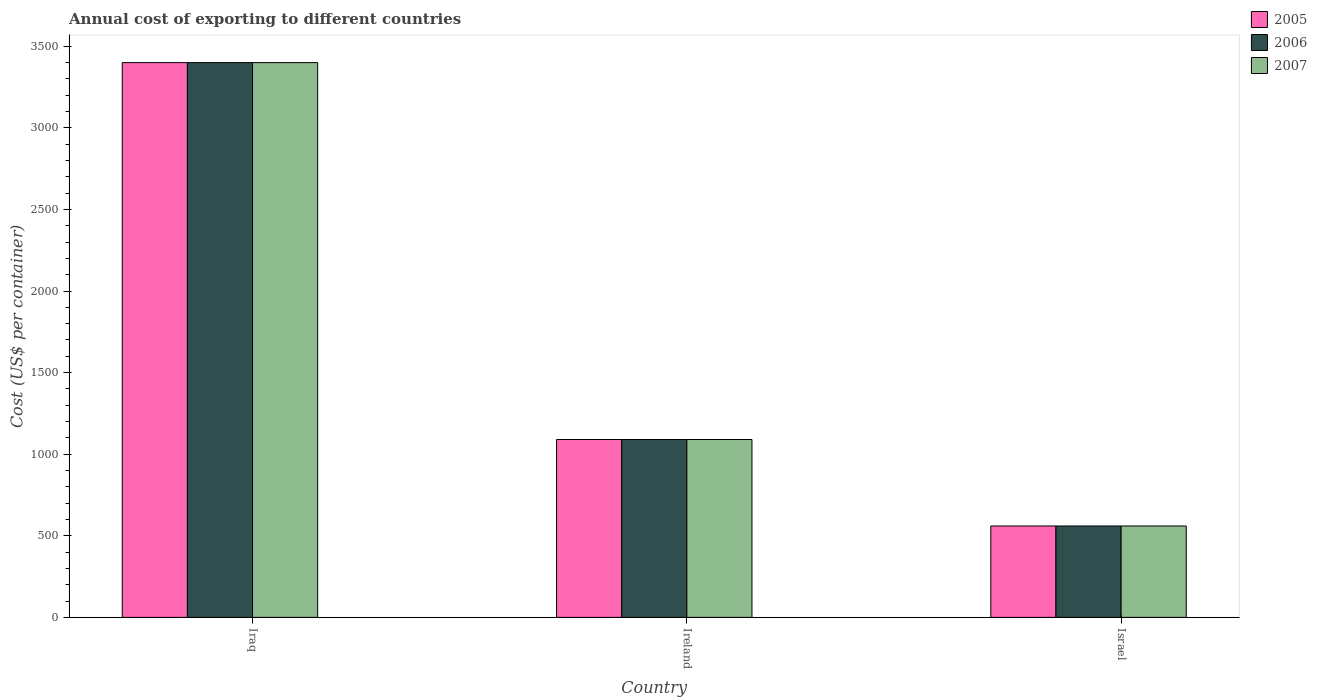How many groups of bars are there?
Give a very brief answer. 3. Are the number of bars per tick equal to the number of legend labels?
Keep it short and to the point. Yes. Are the number of bars on each tick of the X-axis equal?
Your response must be concise. Yes. How many bars are there on the 3rd tick from the left?
Keep it short and to the point. 3. How many bars are there on the 2nd tick from the right?
Ensure brevity in your answer.  3. What is the label of the 1st group of bars from the left?
Your response must be concise. Iraq. In how many cases, is the number of bars for a given country not equal to the number of legend labels?
Provide a short and direct response. 0. What is the total annual cost of exporting in 2005 in Israel?
Give a very brief answer. 560. Across all countries, what is the maximum total annual cost of exporting in 2007?
Your answer should be compact. 3400. Across all countries, what is the minimum total annual cost of exporting in 2006?
Offer a terse response. 560. In which country was the total annual cost of exporting in 2005 maximum?
Your answer should be very brief. Iraq. What is the total total annual cost of exporting in 2005 in the graph?
Offer a very short reply. 5050. What is the difference between the total annual cost of exporting in 2005 in Ireland and that in Israel?
Offer a very short reply. 530. What is the difference between the total annual cost of exporting in 2007 in Israel and the total annual cost of exporting in 2005 in Iraq?
Offer a very short reply. -2840. What is the average total annual cost of exporting in 2006 per country?
Provide a succinct answer. 1683.33. What is the difference between the total annual cost of exporting of/in 2006 and total annual cost of exporting of/in 2007 in Israel?
Your answer should be compact. 0. What is the ratio of the total annual cost of exporting in 2007 in Ireland to that in Israel?
Make the answer very short. 1.95. Is the difference between the total annual cost of exporting in 2006 in Ireland and Israel greater than the difference between the total annual cost of exporting in 2007 in Ireland and Israel?
Offer a very short reply. No. What is the difference between the highest and the second highest total annual cost of exporting in 2006?
Your answer should be compact. 2310. What is the difference between the highest and the lowest total annual cost of exporting in 2006?
Keep it short and to the point. 2840. In how many countries, is the total annual cost of exporting in 2006 greater than the average total annual cost of exporting in 2006 taken over all countries?
Provide a succinct answer. 1. What does the 3rd bar from the left in Ireland represents?
Your response must be concise. 2007. What does the 3rd bar from the right in Israel represents?
Your response must be concise. 2005. Is it the case that in every country, the sum of the total annual cost of exporting in 2005 and total annual cost of exporting in 2006 is greater than the total annual cost of exporting in 2007?
Your response must be concise. Yes. How many countries are there in the graph?
Offer a terse response. 3. Are the values on the major ticks of Y-axis written in scientific E-notation?
Your answer should be very brief. No. Does the graph contain grids?
Ensure brevity in your answer.  No. Where does the legend appear in the graph?
Your response must be concise. Top right. How many legend labels are there?
Provide a short and direct response. 3. What is the title of the graph?
Ensure brevity in your answer.  Annual cost of exporting to different countries. Does "2011" appear as one of the legend labels in the graph?
Offer a very short reply. No. What is the label or title of the X-axis?
Offer a very short reply. Country. What is the label or title of the Y-axis?
Give a very brief answer. Cost (US$ per container). What is the Cost (US$ per container) in 2005 in Iraq?
Your answer should be very brief. 3400. What is the Cost (US$ per container) in 2006 in Iraq?
Ensure brevity in your answer.  3400. What is the Cost (US$ per container) in 2007 in Iraq?
Provide a short and direct response. 3400. What is the Cost (US$ per container) in 2005 in Ireland?
Make the answer very short. 1090. What is the Cost (US$ per container) of 2006 in Ireland?
Offer a very short reply. 1090. What is the Cost (US$ per container) in 2007 in Ireland?
Offer a very short reply. 1090. What is the Cost (US$ per container) in 2005 in Israel?
Offer a very short reply. 560. What is the Cost (US$ per container) in 2006 in Israel?
Your response must be concise. 560. What is the Cost (US$ per container) in 2007 in Israel?
Make the answer very short. 560. Across all countries, what is the maximum Cost (US$ per container) of 2005?
Your answer should be compact. 3400. Across all countries, what is the maximum Cost (US$ per container) of 2006?
Your answer should be compact. 3400. Across all countries, what is the maximum Cost (US$ per container) of 2007?
Keep it short and to the point. 3400. Across all countries, what is the minimum Cost (US$ per container) of 2005?
Keep it short and to the point. 560. Across all countries, what is the minimum Cost (US$ per container) in 2006?
Offer a terse response. 560. Across all countries, what is the minimum Cost (US$ per container) in 2007?
Offer a very short reply. 560. What is the total Cost (US$ per container) of 2005 in the graph?
Keep it short and to the point. 5050. What is the total Cost (US$ per container) of 2006 in the graph?
Ensure brevity in your answer.  5050. What is the total Cost (US$ per container) in 2007 in the graph?
Your answer should be compact. 5050. What is the difference between the Cost (US$ per container) in 2005 in Iraq and that in Ireland?
Provide a short and direct response. 2310. What is the difference between the Cost (US$ per container) of 2006 in Iraq and that in Ireland?
Keep it short and to the point. 2310. What is the difference between the Cost (US$ per container) in 2007 in Iraq and that in Ireland?
Your answer should be very brief. 2310. What is the difference between the Cost (US$ per container) in 2005 in Iraq and that in Israel?
Ensure brevity in your answer.  2840. What is the difference between the Cost (US$ per container) in 2006 in Iraq and that in Israel?
Offer a very short reply. 2840. What is the difference between the Cost (US$ per container) of 2007 in Iraq and that in Israel?
Provide a succinct answer. 2840. What is the difference between the Cost (US$ per container) in 2005 in Ireland and that in Israel?
Offer a very short reply. 530. What is the difference between the Cost (US$ per container) of 2006 in Ireland and that in Israel?
Ensure brevity in your answer.  530. What is the difference between the Cost (US$ per container) of 2007 in Ireland and that in Israel?
Make the answer very short. 530. What is the difference between the Cost (US$ per container) in 2005 in Iraq and the Cost (US$ per container) in 2006 in Ireland?
Your response must be concise. 2310. What is the difference between the Cost (US$ per container) of 2005 in Iraq and the Cost (US$ per container) of 2007 in Ireland?
Make the answer very short. 2310. What is the difference between the Cost (US$ per container) in 2006 in Iraq and the Cost (US$ per container) in 2007 in Ireland?
Provide a short and direct response. 2310. What is the difference between the Cost (US$ per container) of 2005 in Iraq and the Cost (US$ per container) of 2006 in Israel?
Provide a succinct answer. 2840. What is the difference between the Cost (US$ per container) of 2005 in Iraq and the Cost (US$ per container) of 2007 in Israel?
Ensure brevity in your answer.  2840. What is the difference between the Cost (US$ per container) of 2006 in Iraq and the Cost (US$ per container) of 2007 in Israel?
Make the answer very short. 2840. What is the difference between the Cost (US$ per container) in 2005 in Ireland and the Cost (US$ per container) in 2006 in Israel?
Make the answer very short. 530. What is the difference between the Cost (US$ per container) of 2005 in Ireland and the Cost (US$ per container) of 2007 in Israel?
Make the answer very short. 530. What is the difference between the Cost (US$ per container) of 2006 in Ireland and the Cost (US$ per container) of 2007 in Israel?
Offer a terse response. 530. What is the average Cost (US$ per container) in 2005 per country?
Give a very brief answer. 1683.33. What is the average Cost (US$ per container) in 2006 per country?
Offer a very short reply. 1683.33. What is the average Cost (US$ per container) of 2007 per country?
Give a very brief answer. 1683.33. What is the difference between the Cost (US$ per container) of 2005 and Cost (US$ per container) of 2006 in Ireland?
Offer a terse response. 0. What is the difference between the Cost (US$ per container) of 2005 and Cost (US$ per container) of 2007 in Israel?
Your response must be concise. 0. What is the difference between the Cost (US$ per container) of 2006 and Cost (US$ per container) of 2007 in Israel?
Keep it short and to the point. 0. What is the ratio of the Cost (US$ per container) of 2005 in Iraq to that in Ireland?
Keep it short and to the point. 3.12. What is the ratio of the Cost (US$ per container) of 2006 in Iraq to that in Ireland?
Offer a terse response. 3.12. What is the ratio of the Cost (US$ per container) in 2007 in Iraq to that in Ireland?
Provide a succinct answer. 3.12. What is the ratio of the Cost (US$ per container) of 2005 in Iraq to that in Israel?
Your response must be concise. 6.07. What is the ratio of the Cost (US$ per container) in 2006 in Iraq to that in Israel?
Keep it short and to the point. 6.07. What is the ratio of the Cost (US$ per container) of 2007 in Iraq to that in Israel?
Make the answer very short. 6.07. What is the ratio of the Cost (US$ per container) in 2005 in Ireland to that in Israel?
Ensure brevity in your answer.  1.95. What is the ratio of the Cost (US$ per container) of 2006 in Ireland to that in Israel?
Keep it short and to the point. 1.95. What is the ratio of the Cost (US$ per container) in 2007 in Ireland to that in Israel?
Offer a terse response. 1.95. What is the difference between the highest and the second highest Cost (US$ per container) of 2005?
Give a very brief answer. 2310. What is the difference between the highest and the second highest Cost (US$ per container) of 2006?
Provide a succinct answer. 2310. What is the difference between the highest and the second highest Cost (US$ per container) in 2007?
Make the answer very short. 2310. What is the difference between the highest and the lowest Cost (US$ per container) of 2005?
Your answer should be compact. 2840. What is the difference between the highest and the lowest Cost (US$ per container) in 2006?
Make the answer very short. 2840. What is the difference between the highest and the lowest Cost (US$ per container) of 2007?
Your response must be concise. 2840. 